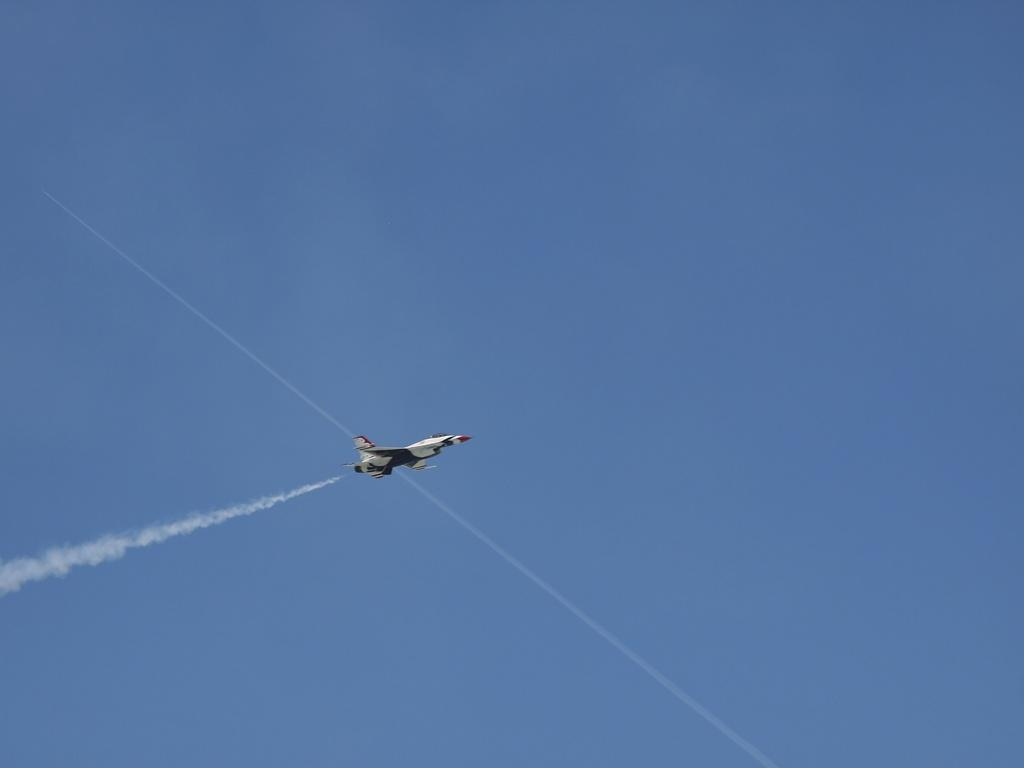What is the main subject of the image? There is an aircraft in the center of the image. How would you describe the weather in the image? The sky is clear in the image. What can be seen on the left side of the image? There is smoke visible on the left side of the image. How many people are sleeping in the aircraft in the image? There is no information about people sleeping in the aircraft in the image. Can you tell me when the birth of the aircraft took place in the image? The image does not provide information about the birth of the aircraft. 